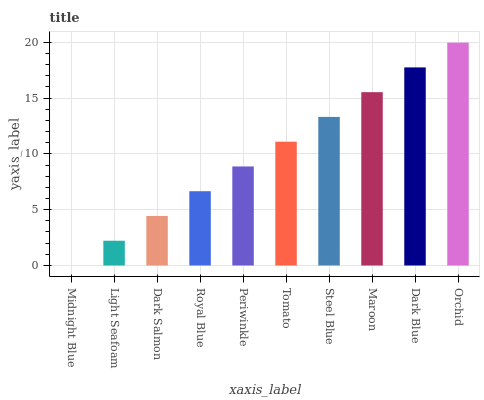Is Midnight Blue the minimum?
Answer yes or no. Yes. Is Orchid the maximum?
Answer yes or no. Yes. Is Light Seafoam the minimum?
Answer yes or no. No. Is Light Seafoam the maximum?
Answer yes or no. No. Is Light Seafoam greater than Midnight Blue?
Answer yes or no. Yes. Is Midnight Blue less than Light Seafoam?
Answer yes or no. Yes. Is Midnight Blue greater than Light Seafoam?
Answer yes or no. No. Is Light Seafoam less than Midnight Blue?
Answer yes or no. No. Is Tomato the high median?
Answer yes or no. Yes. Is Periwinkle the low median?
Answer yes or no. Yes. Is Maroon the high median?
Answer yes or no. No. Is Light Seafoam the low median?
Answer yes or no. No. 